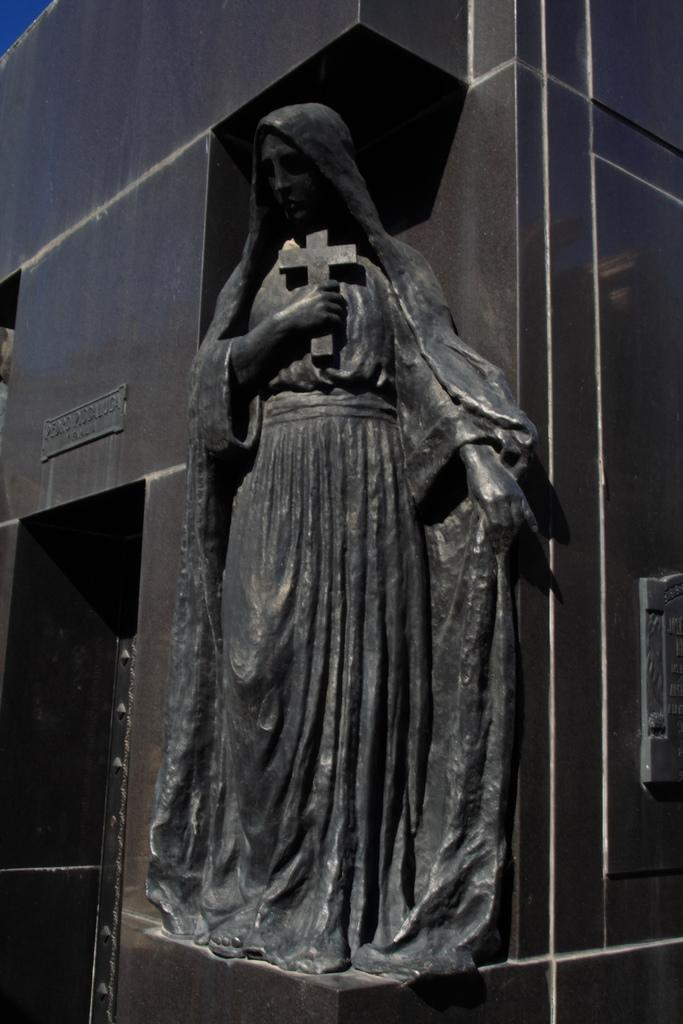What is the statue holding in the image? The statue is holding a cross in the image. What can be seen in the background of the image? There is a wall in the background of the image. What is written on the board that is attached to the wall? The provided facts do not mention the content of the writing on the board. Can you describe the wall in the image? The wall is in the background of the image, and a board with writing is attached to it. How does the wind affect the statue in the image? The provided facts do not mention any wind in the image, so we cannot determine its effect on the statue. 